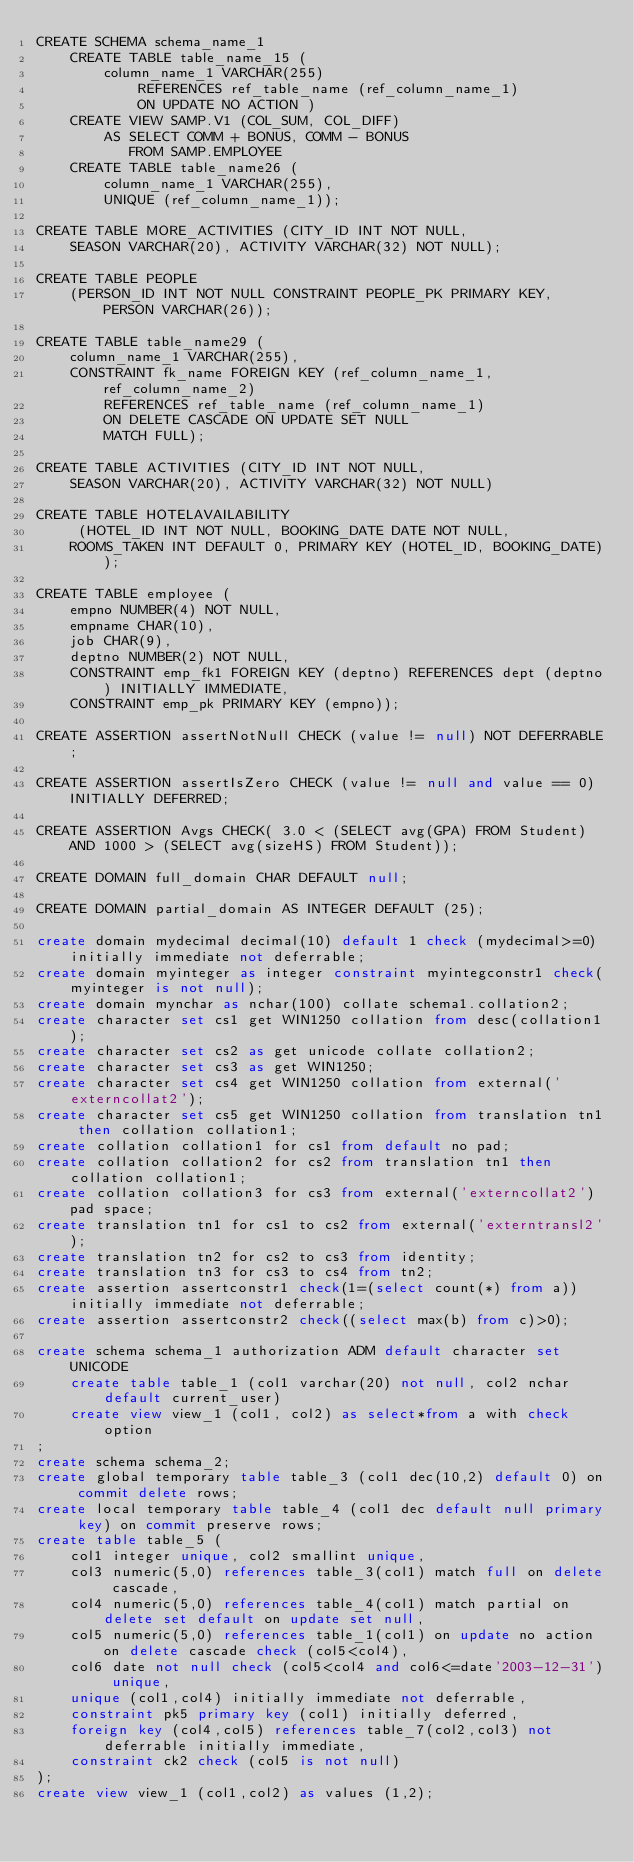Convert code to text. <code><loc_0><loc_0><loc_500><loc_500><_SQL_>CREATE SCHEMA schema_name_1
    CREATE TABLE table_name_15 (
        column_name_1 VARCHAR(255) 
            REFERENCES ref_table_name (ref_column_name_1) 
            ON UPDATE NO ACTION )
    CREATE VIEW SAMP.V1 (COL_SUM, COL_DIFF)
        AS SELECT COMM + BONUS, COMM - BONUS
           FROM SAMP.EMPLOYEE
    CREATE TABLE table_name26 (
        column_name_1 VARCHAR(255),
        UNIQUE (ref_column_name_1));
   
CREATE TABLE MORE_ACTIVITIES (CITY_ID INT NOT NULL,
    SEASON VARCHAR(20), ACTIVITY VARCHAR(32) NOT NULL);

CREATE TABLE PEOPLE
    (PERSON_ID INT NOT NULL CONSTRAINT PEOPLE_PK PRIMARY KEY, PERSON VARCHAR(26));
 
CREATE TABLE table_name29 (
    column_name_1 VARCHAR(255),
    CONSTRAINT fk_name FOREIGN KEY (ref_column_name_1, ref_column_name_2)
        REFERENCES ref_table_name (ref_column_name_1)
        ON DELETE CASCADE ON UPDATE SET NULL
        MATCH FULL);
        
CREATE TABLE ACTIVITIES (CITY_ID INT NOT NULL,
    SEASON VARCHAR(20), ACTIVITY VARCHAR(32) NOT NULL)  

CREATE TABLE HOTELAVAILABILITY
     (HOTEL_ID INT NOT NULL, BOOKING_DATE DATE NOT NULL,
    ROOMS_TAKEN INT DEFAULT 0, PRIMARY KEY (HOTEL_ID, BOOKING_DATE));
    
CREATE TABLE employee (
    empno NUMBER(4) NOT NULL, 
    empname CHAR(10), 
    job CHAR(9), 
    deptno NUMBER(2) NOT NULL,
    CONSTRAINT emp_fk1 FOREIGN KEY (deptno) REFERENCES dept (deptno) INITIALLY IMMEDIATE, 
    CONSTRAINT emp_pk PRIMARY KEY (empno));

CREATE ASSERTION assertNotNull CHECK (value != null) NOT DEFERRABLE;

CREATE ASSERTION assertIsZero CHECK (value != null and value == 0) INITIALLY DEFERRED;

CREATE ASSERTION Avgs CHECK( 3.0 < (SELECT avg(GPA) FROM Student) AND 1000 > (SELECT avg(sizeHS) FROM Student));

CREATE DOMAIN full_domain CHAR DEFAULT null;

CREATE DOMAIN partial_domain AS INTEGER DEFAULT (25);

create domain mydecimal decimal(10) default 1 check (mydecimal>=0) initially immediate not deferrable;
create domain myinteger as integer constraint myintegconstr1 check(myinteger is not null);
create domain mynchar as nchar(100) collate schema1.collation2;
create character set cs1 get WIN1250 collation from desc(collation1);
create character set cs2 as get unicode collate collation2;
create character set cs3 as get WIN1250;
create character set cs4 get WIN1250 collation from external('externcollat2');
create character set cs5 get WIN1250 collation from translation tn1 then collation collation1;
create collation collation1 for cs1 from default no pad;
create collation collation2 for cs2 from translation tn1 then collation collation1;
create collation collation3 for cs3 from external('externcollat2') pad space;
create translation tn1 for cs1 to cs2 from external('externtransl2');
create translation tn2 for cs2 to cs3 from identity;
create translation tn3 for cs3 to cs4 from tn2;
create assertion assertconstr1 check(1=(select count(*) from a)) initially immediate not deferrable;
create assertion assertconstr2 check((select max(b) from c)>0);

create schema schema_1 authorization ADM default character set UNICODE 
    create table table_1 (col1 varchar(20) not null, col2 nchar default current_user)
    create view view_1 (col1, col2) as select*from a with check option
;
create schema schema_2;
create global temporary table table_3 (col1 dec(10,2) default 0) on commit delete rows;
create local temporary table table_4 (col1 dec default null primary key) on commit preserve rows;
create table table_5 (
    col1 integer unique, col2 smallint unique,
    col3 numeric(5,0) references table_3(col1) match full on delete cascade,
    col4 numeric(5,0) references table_4(col1) match partial on delete set default on update set null,
    col5 numeric(5,0) references table_1(col1) on update no action on delete cascade check (col5<col4),
    col6 date not null check (col5<col4 and col6<=date'2003-12-31') unique,
    unique (col1,col4) initially immediate not deferrable,
    constraint pk5 primary key (col1) initially deferred,
    foreign key (col4,col5) references table_7(col2,col3) not deferrable initially immediate,
    constraint ck2 check (col5 is not null)
);
create view view_1 (col1,col2) as values (1,2);</code> 